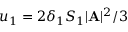Convert formula to latex. <formula><loc_0><loc_0><loc_500><loc_500>u _ { 1 } = 2 \delta _ { 1 } S _ { 1 } | { A } | ^ { 2 } / 3</formula> 